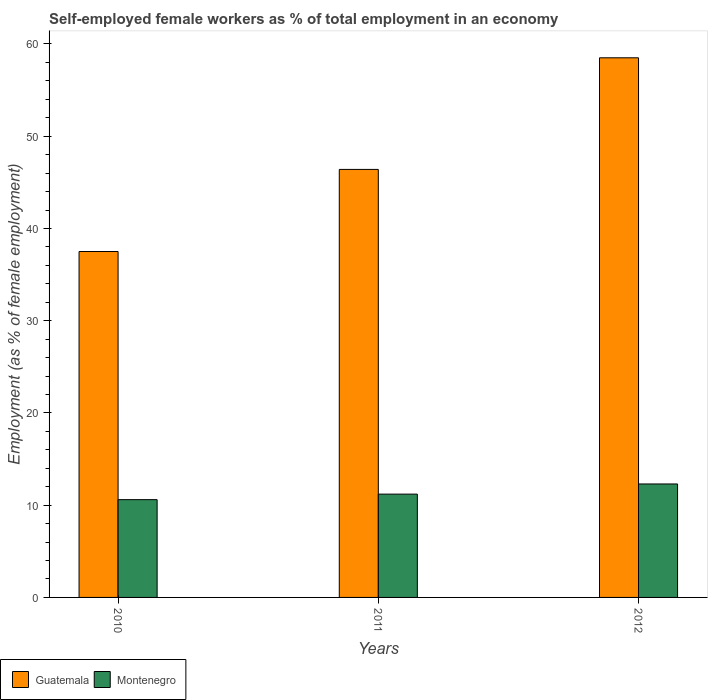Are the number of bars on each tick of the X-axis equal?
Your response must be concise. Yes. How many bars are there on the 1st tick from the left?
Keep it short and to the point. 2. What is the label of the 3rd group of bars from the left?
Make the answer very short. 2012. In how many cases, is the number of bars for a given year not equal to the number of legend labels?
Your answer should be compact. 0. What is the percentage of self-employed female workers in Montenegro in 2011?
Keep it short and to the point. 11.2. Across all years, what is the maximum percentage of self-employed female workers in Guatemala?
Provide a succinct answer. 58.5. Across all years, what is the minimum percentage of self-employed female workers in Montenegro?
Your response must be concise. 10.6. What is the total percentage of self-employed female workers in Montenegro in the graph?
Give a very brief answer. 34.1. What is the difference between the percentage of self-employed female workers in Guatemala in 2011 and that in 2012?
Offer a very short reply. -12.1. What is the difference between the percentage of self-employed female workers in Montenegro in 2011 and the percentage of self-employed female workers in Guatemala in 2012?
Offer a very short reply. -47.3. What is the average percentage of self-employed female workers in Montenegro per year?
Your response must be concise. 11.37. In the year 2010, what is the difference between the percentage of self-employed female workers in Montenegro and percentage of self-employed female workers in Guatemala?
Offer a terse response. -26.9. In how many years, is the percentage of self-employed female workers in Guatemala greater than 30 %?
Your response must be concise. 3. What is the ratio of the percentage of self-employed female workers in Guatemala in 2011 to that in 2012?
Offer a very short reply. 0.79. Is the difference between the percentage of self-employed female workers in Montenegro in 2010 and 2012 greater than the difference between the percentage of self-employed female workers in Guatemala in 2010 and 2012?
Provide a short and direct response. Yes. What is the difference between the highest and the second highest percentage of self-employed female workers in Guatemala?
Offer a terse response. 12.1. What is the difference between the highest and the lowest percentage of self-employed female workers in Montenegro?
Provide a succinct answer. 1.7. In how many years, is the percentage of self-employed female workers in Guatemala greater than the average percentage of self-employed female workers in Guatemala taken over all years?
Provide a succinct answer. 1. Is the sum of the percentage of self-employed female workers in Guatemala in 2010 and 2011 greater than the maximum percentage of self-employed female workers in Montenegro across all years?
Offer a terse response. Yes. What does the 1st bar from the left in 2011 represents?
Your answer should be very brief. Guatemala. What does the 1st bar from the right in 2011 represents?
Provide a short and direct response. Montenegro. How many bars are there?
Provide a short and direct response. 6. Are all the bars in the graph horizontal?
Your response must be concise. No. How many years are there in the graph?
Your answer should be very brief. 3. Are the values on the major ticks of Y-axis written in scientific E-notation?
Offer a terse response. No. Does the graph contain any zero values?
Provide a short and direct response. No. Does the graph contain grids?
Provide a succinct answer. No. Where does the legend appear in the graph?
Offer a terse response. Bottom left. How many legend labels are there?
Offer a terse response. 2. What is the title of the graph?
Offer a very short reply. Self-employed female workers as % of total employment in an economy. Does "Sao Tome and Principe" appear as one of the legend labels in the graph?
Offer a terse response. No. What is the label or title of the X-axis?
Offer a very short reply. Years. What is the label or title of the Y-axis?
Offer a terse response. Employment (as % of female employment). What is the Employment (as % of female employment) of Guatemala in 2010?
Give a very brief answer. 37.5. What is the Employment (as % of female employment) of Montenegro in 2010?
Your answer should be compact. 10.6. What is the Employment (as % of female employment) in Guatemala in 2011?
Give a very brief answer. 46.4. What is the Employment (as % of female employment) in Montenegro in 2011?
Provide a succinct answer. 11.2. What is the Employment (as % of female employment) of Guatemala in 2012?
Provide a short and direct response. 58.5. What is the Employment (as % of female employment) in Montenegro in 2012?
Make the answer very short. 12.3. Across all years, what is the maximum Employment (as % of female employment) of Guatemala?
Keep it short and to the point. 58.5. Across all years, what is the maximum Employment (as % of female employment) in Montenegro?
Give a very brief answer. 12.3. Across all years, what is the minimum Employment (as % of female employment) of Guatemala?
Make the answer very short. 37.5. Across all years, what is the minimum Employment (as % of female employment) of Montenegro?
Keep it short and to the point. 10.6. What is the total Employment (as % of female employment) of Guatemala in the graph?
Ensure brevity in your answer.  142.4. What is the total Employment (as % of female employment) in Montenegro in the graph?
Provide a succinct answer. 34.1. What is the difference between the Employment (as % of female employment) in Guatemala in 2010 and that in 2011?
Make the answer very short. -8.9. What is the difference between the Employment (as % of female employment) in Montenegro in 2010 and that in 2011?
Give a very brief answer. -0.6. What is the difference between the Employment (as % of female employment) of Guatemala in 2010 and that in 2012?
Your answer should be compact. -21. What is the difference between the Employment (as % of female employment) of Guatemala in 2011 and that in 2012?
Provide a short and direct response. -12.1. What is the difference between the Employment (as % of female employment) of Guatemala in 2010 and the Employment (as % of female employment) of Montenegro in 2011?
Keep it short and to the point. 26.3. What is the difference between the Employment (as % of female employment) in Guatemala in 2010 and the Employment (as % of female employment) in Montenegro in 2012?
Make the answer very short. 25.2. What is the difference between the Employment (as % of female employment) of Guatemala in 2011 and the Employment (as % of female employment) of Montenegro in 2012?
Keep it short and to the point. 34.1. What is the average Employment (as % of female employment) in Guatemala per year?
Ensure brevity in your answer.  47.47. What is the average Employment (as % of female employment) in Montenegro per year?
Keep it short and to the point. 11.37. In the year 2010, what is the difference between the Employment (as % of female employment) of Guatemala and Employment (as % of female employment) of Montenegro?
Provide a short and direct response. 26.9. In the year 2011, what is the difference between the Employment (as % of female employment) in Guatemala and Employment (as % of female employment) in Montenegro?
Provide a succinct answer. 35.2. In the year 2012, what is the difference between the Employment (as % of female employment) in Guatemala and Employment (as % of female employment) in Montenegro?
Your answer should be very brief. 46.2. What is the ratio of the Employment (as % of female employment) of Guatemala in 2010 to that in 2011?
Make the answer very short. 0.81. What is the ratio of the Employment (as % of female employment) in Montenegro in 2010 to that in 2011?
Give a very brief answer. 0.95. What is the ratio of the Employment (as % of female employment) in Guatemala in 2010 to that in 2012?
Provide a short and direct response. 0.64. What is the ratio of the Employment (as % of female employment) in Montenegro in 2010 to that in 2012?
Offer a terse response. 0.86. What is the ratio of the Employment (as % of female employment) of Guatemala in 2011 to that in 2012?
Provide a succinct answer. 0.79. What is the ratio of the Employment (as % of female employment) of Montenegro in 2011 to that in 2012?
Make the answer very short. 0.91. What is the difference between the highest and the second highest Employment (as % of female employment) of Montenegro?
Provide a short and direct response. 1.1. What is the difference between the highest and the lowest Employment (as % of female employment) of Guatemala?
Provide a short and direct response. 21. What is the difference between the highest and the lowest Employment (as % of female employment) of Montenegro?
Keep it short and to the point. 1.7. 